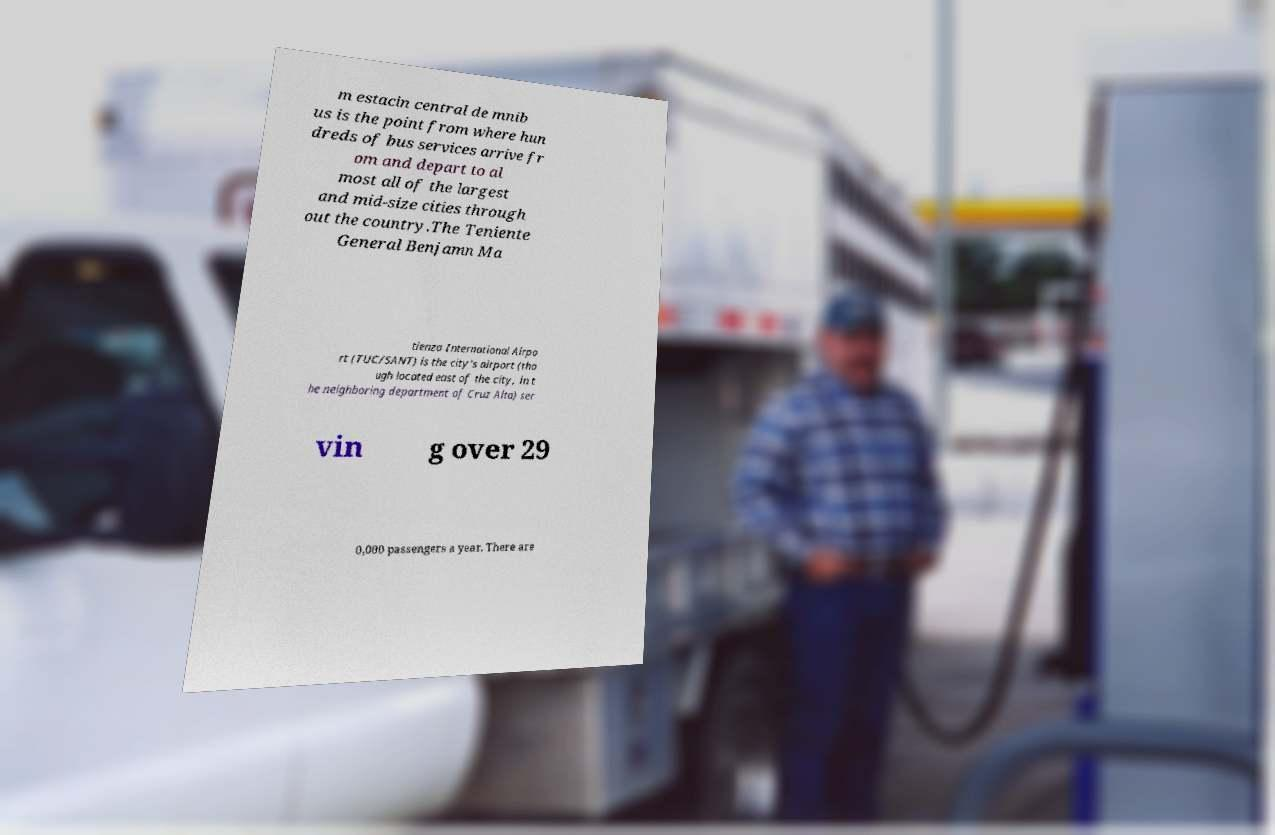I need the written content from this picture converted into text. Can you do that? m estacin central de mnib us is the point from where hun dreds of bus services arrive fr om and depart to al most all of the largest and mid-size cities through out the country.The Teniente General Benjamn Ma tienzo International Airpo rt (TUC/SANT) is the city's airport (tho ugh located east of the city, in t he neighboring department of Cruz Alta) ser vin g over 29 0,000 passengers a year. There are 